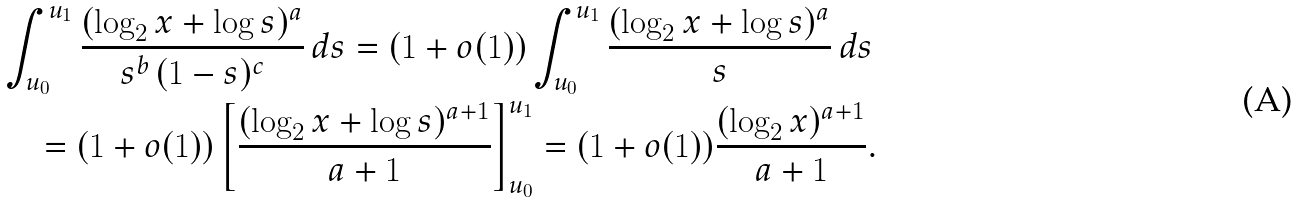Convert formula to latex. <formula><loc_0><loc_0><loc_500><loc_500>& \int _ { u _ { 0 } } ^ { u _ { 1 } } \frac { ( \log _ { 2 } x + \log s ) ^ { a } } { s ^ { b } \, ( 1 - s ) ^ { c } } \, d s = ( 1 + o ( 1 ) ) \int _ { u _ { 0 } } ^ { u _ { 1 } } \frac { ( \log _ { 2 } x + \log s ) ^ { a } } { s } \, d s \\ & \quad = ( 1 + o ( 1 ) ) \left [ \frac { ( \log _ { 2 } x + \log s ) ^ { a + 1 } } { a + 1 } \right ] _ { u _ { 0 } } ^ { u _ { 1 } } = ( 1 + o ( 1 ) ) \frac { ( \log _ { 2 } x ) ^ { a + 1 } } { a + 1 } .</formula> 